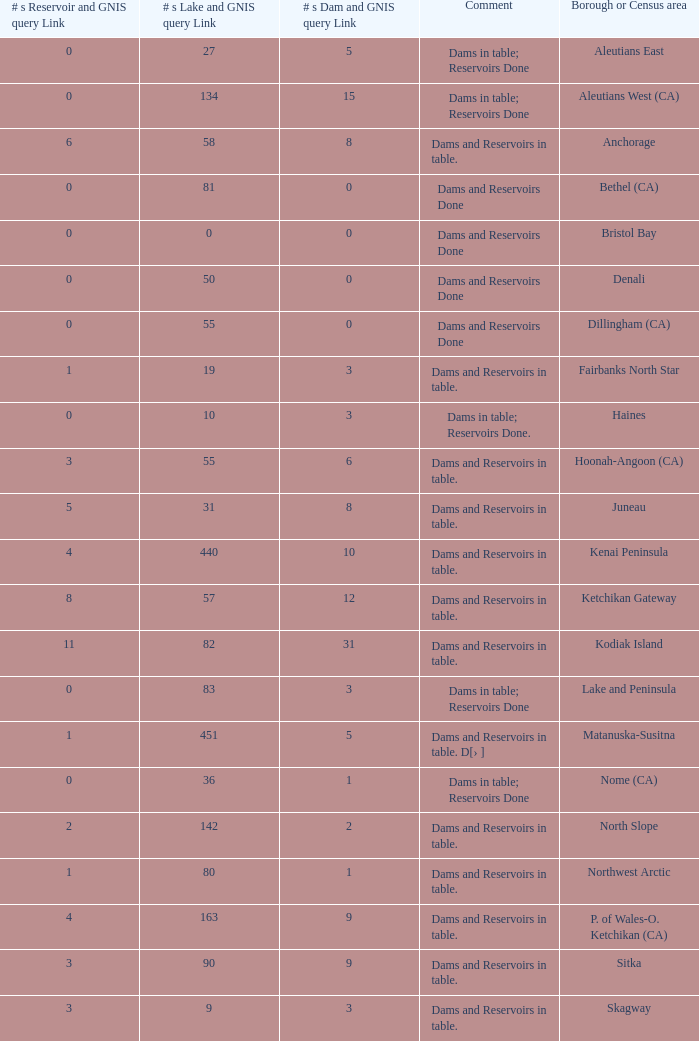Name the minimum number of reservoir for gnis query link where numbers lake gnis query link being 60 5.0. 